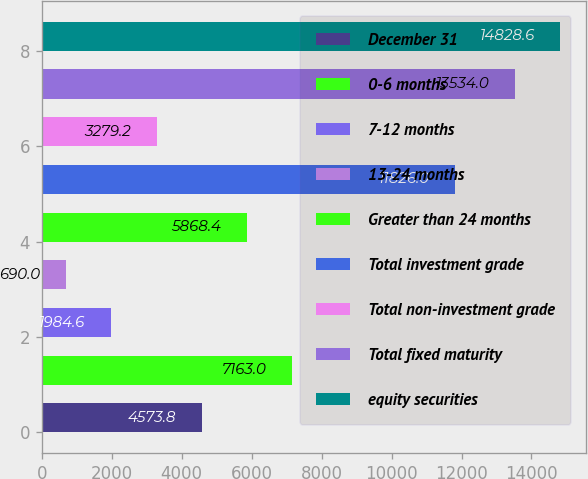Convert chart. <chart><loc_0><loc_0><loc_500><loc_500><bar_chart><fcel>December 31<fcel>0-6 months<fcel>7-12 months<fcel>13-24 months<fcel>Greater than 24 months<fcel>Total investment grade<fcel>Total non-investment grade<fcel>Total fixed maturity<fcel>equity securities<nl><fcel>4573.8<fcel>7163<fcel>1984.6<fcel>690<fcel>5868.4<fcel>11826<fcel>3279.2<fcel>13534<fcel>14828.6<nl></chart> 